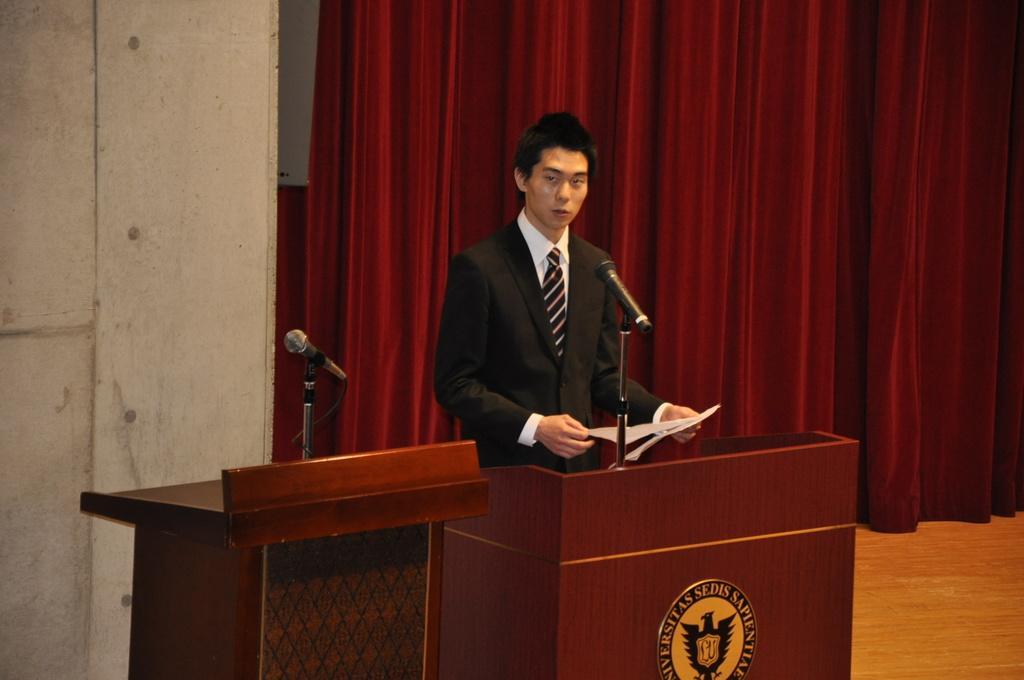Describe this image in one or two sentences. In this image I can see a person is holding paper and wearing black and white dress. In front I can see two mics,podiums and maroon color curtain. 